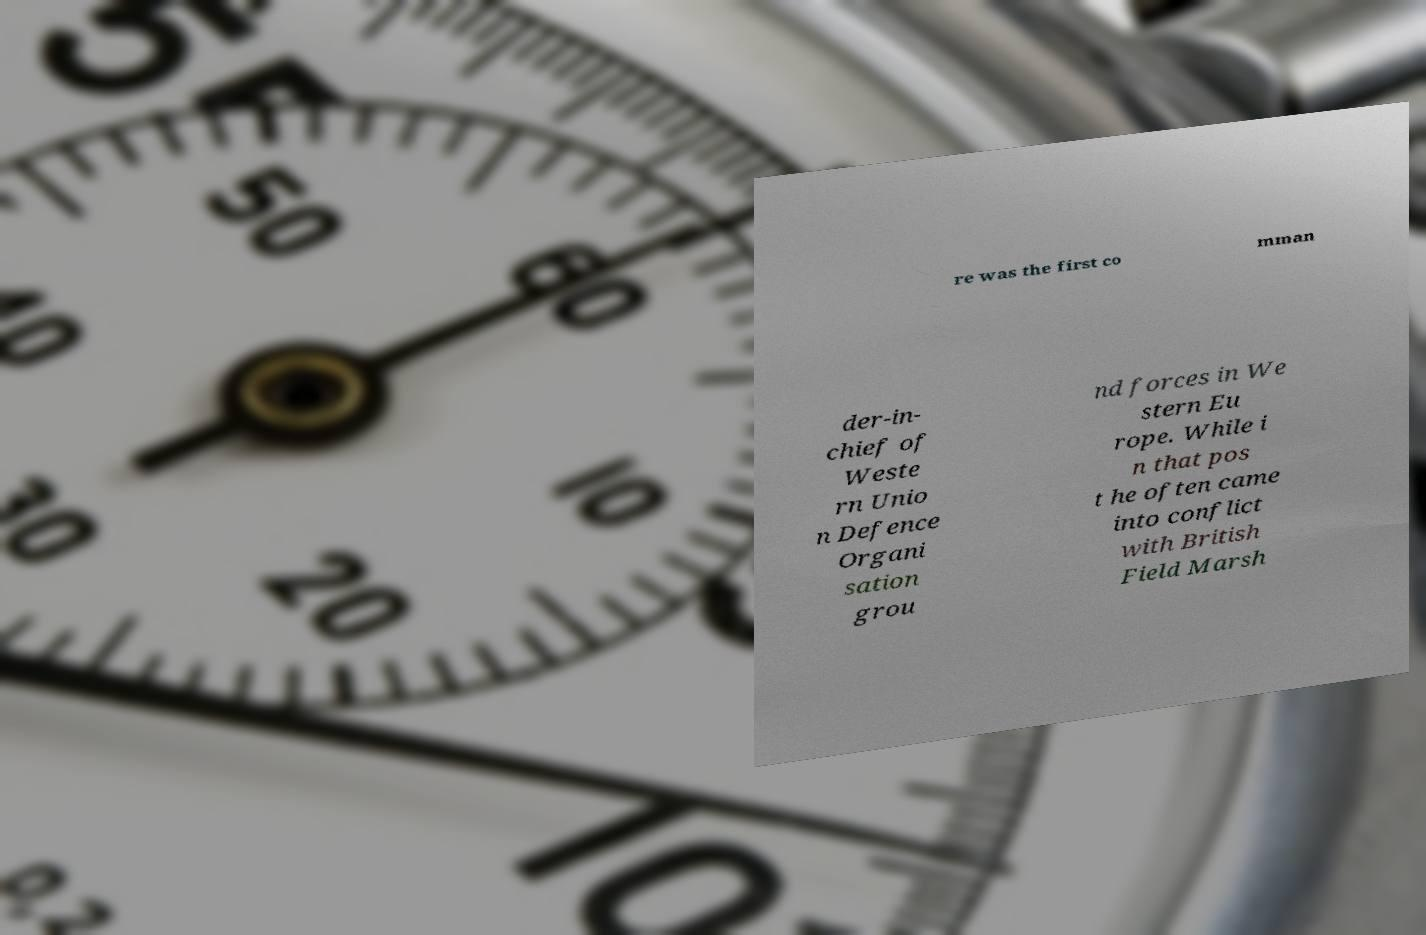Can you read and provide the text displayed in the image?This photo seems to have some interesting text. Can you extract and type it out for me? re was the first co mman der-in- chief of Weste rn Unio n Defence Organi sation grou nd forces in We stern Eu rope. While i n that pos t he often came into conflict with British Field Marsh 